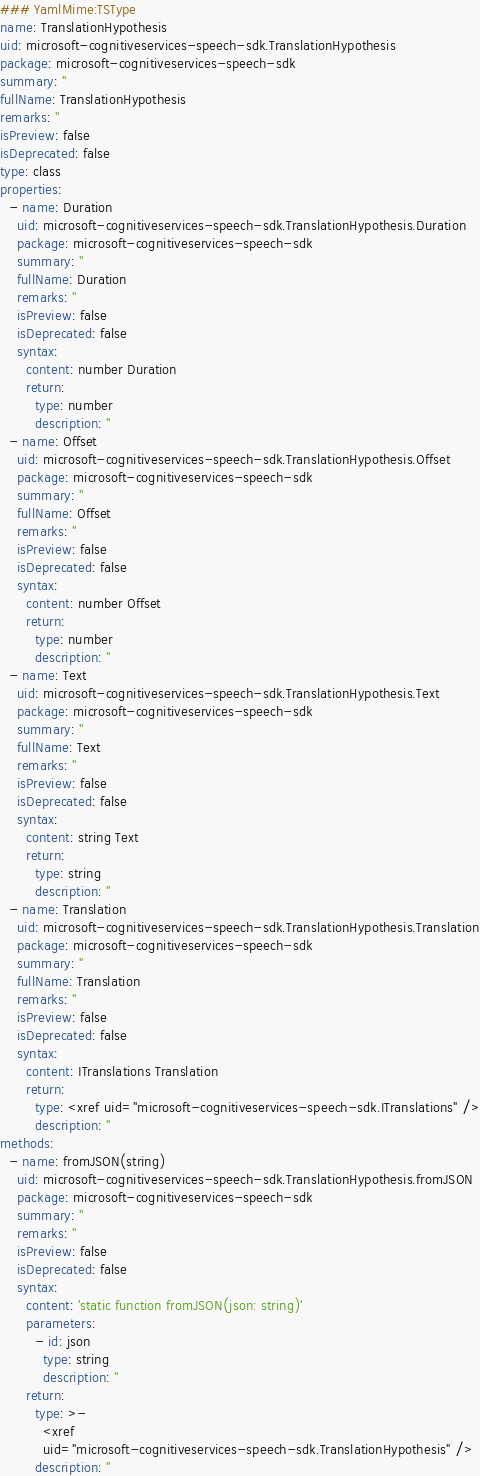Convert code to text. <code><loc_0><loc_0><loc_500><loc_500><_YAML_>### YamlMime:TSType
name: TranslationHypothesis
uid: microsoft-cognitiveservices-speech-sdk.TranslationHypothesis
package: microsoft-cognitiveservices-speech-sdk
summary: ''
fullName: TranslationHypothesis
remarks: ''
isPreview: false
isDeprecated: false
type: class
properties:
  - name: Duration
    uid: microsoft-cognitiveservices-speech-sdk.TranslationHypothesis.Duration
    package: microsoft-cognitiveservices-speech-sdk
    summary: ''
    fullName: Duration
    remarks: ''
    isPreview: false
    isDeprecated: false
    syntax:
      content: number Duration
      return:
        type: number
        description: ''
  - name: Offset
    uid: microsoft-cognitiveservices-speech-sdk.TranslationHypothesis.Offset
    package: microsoft-cognitiveservices-speech-sdk
    summary: ''
    fullName: Offset
    remarks: ''
    isPreview: false
    isDeprecated: false
    syntax:
      content: number Offset
      return:
        type: number
        description: ''
  - name: Text
    uid: microsoft-cognitiveservices-speech-sdk.TranslationHypothesis.Text
    package: microsoft-cognitiveservices-speech-sdk
    summary: ''
    fullName: Text
    remarks: ''
    isPreview: false
    isDeprecated: false
    syntax:
      content: string Text
      return:
        type: string
        description: ''
  - name: Translation
    uid: microsoft-cognitiveservices-speech-sdk.TranslationHypothesis.Translation
    package: microsoft-cognitiveservices-speech-sdk
    summary: ''
    fullName: Translation
    remarks: ''
    isPreview: false
    isDeprecated: false
    syntax:
      content: ITranslations Translation
      return:
        type: <xref uid="microsoft-cognitiveservices-speech-sdk.ITranslations" />
        description: ''
methods:
  - name: fromJSON(string)
    uid: microsoft-cognitiveservices-speech-sdk.TranslationHypothesis.fromJSON
    package: microsoft-cognitiveservices-speech-sdk
    summary: ''
    remarks: ''
    isPreview: false
    isDeprecated: false
    syntax:
      content: 'static function fromJSON(json: string)'
      parameters:
        - id: json
          type: string
          description: ''
      return:
        type: >-
          <xref
          uid="microsoft-cognitiveservices-speech-sdk.TranslationHypothesis" />
        description: ''
</code> 